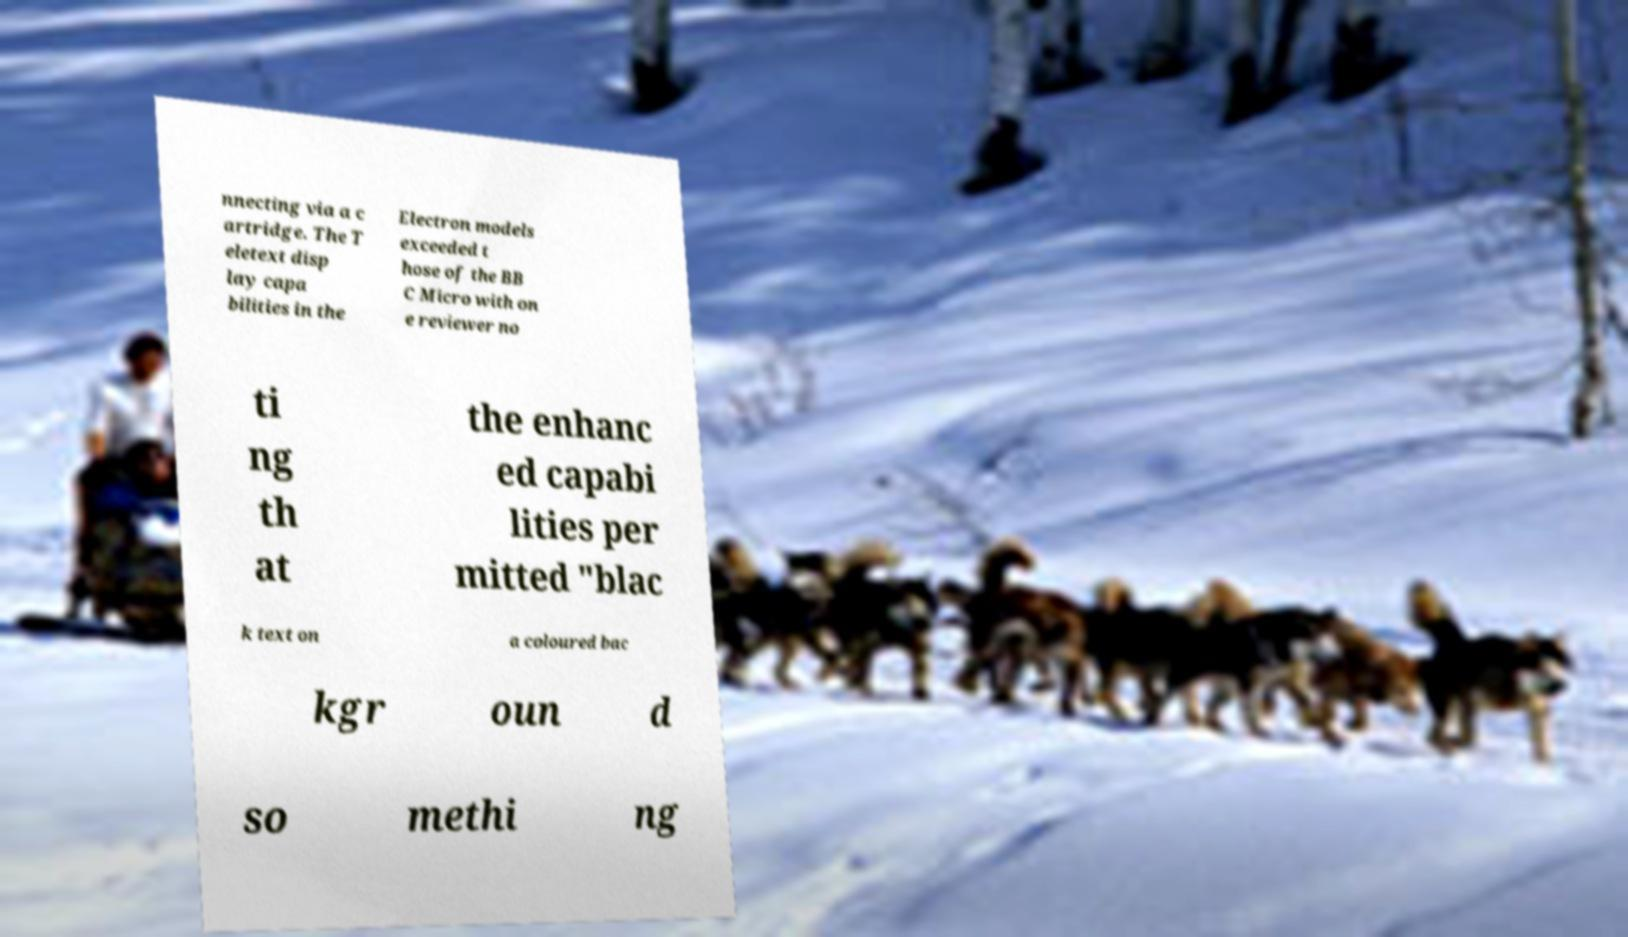Please read and relay the text visible in this image. What does it say? nnecting via a c artridge. The T eletext disp lay capa bilities in the Electron models exceeded t hose of the BB C Micro with on e reviewer no ti ng th at the enhanc ed capabi lities per mitted "blac k text on a coloured bac kgr oun d so methi ng 